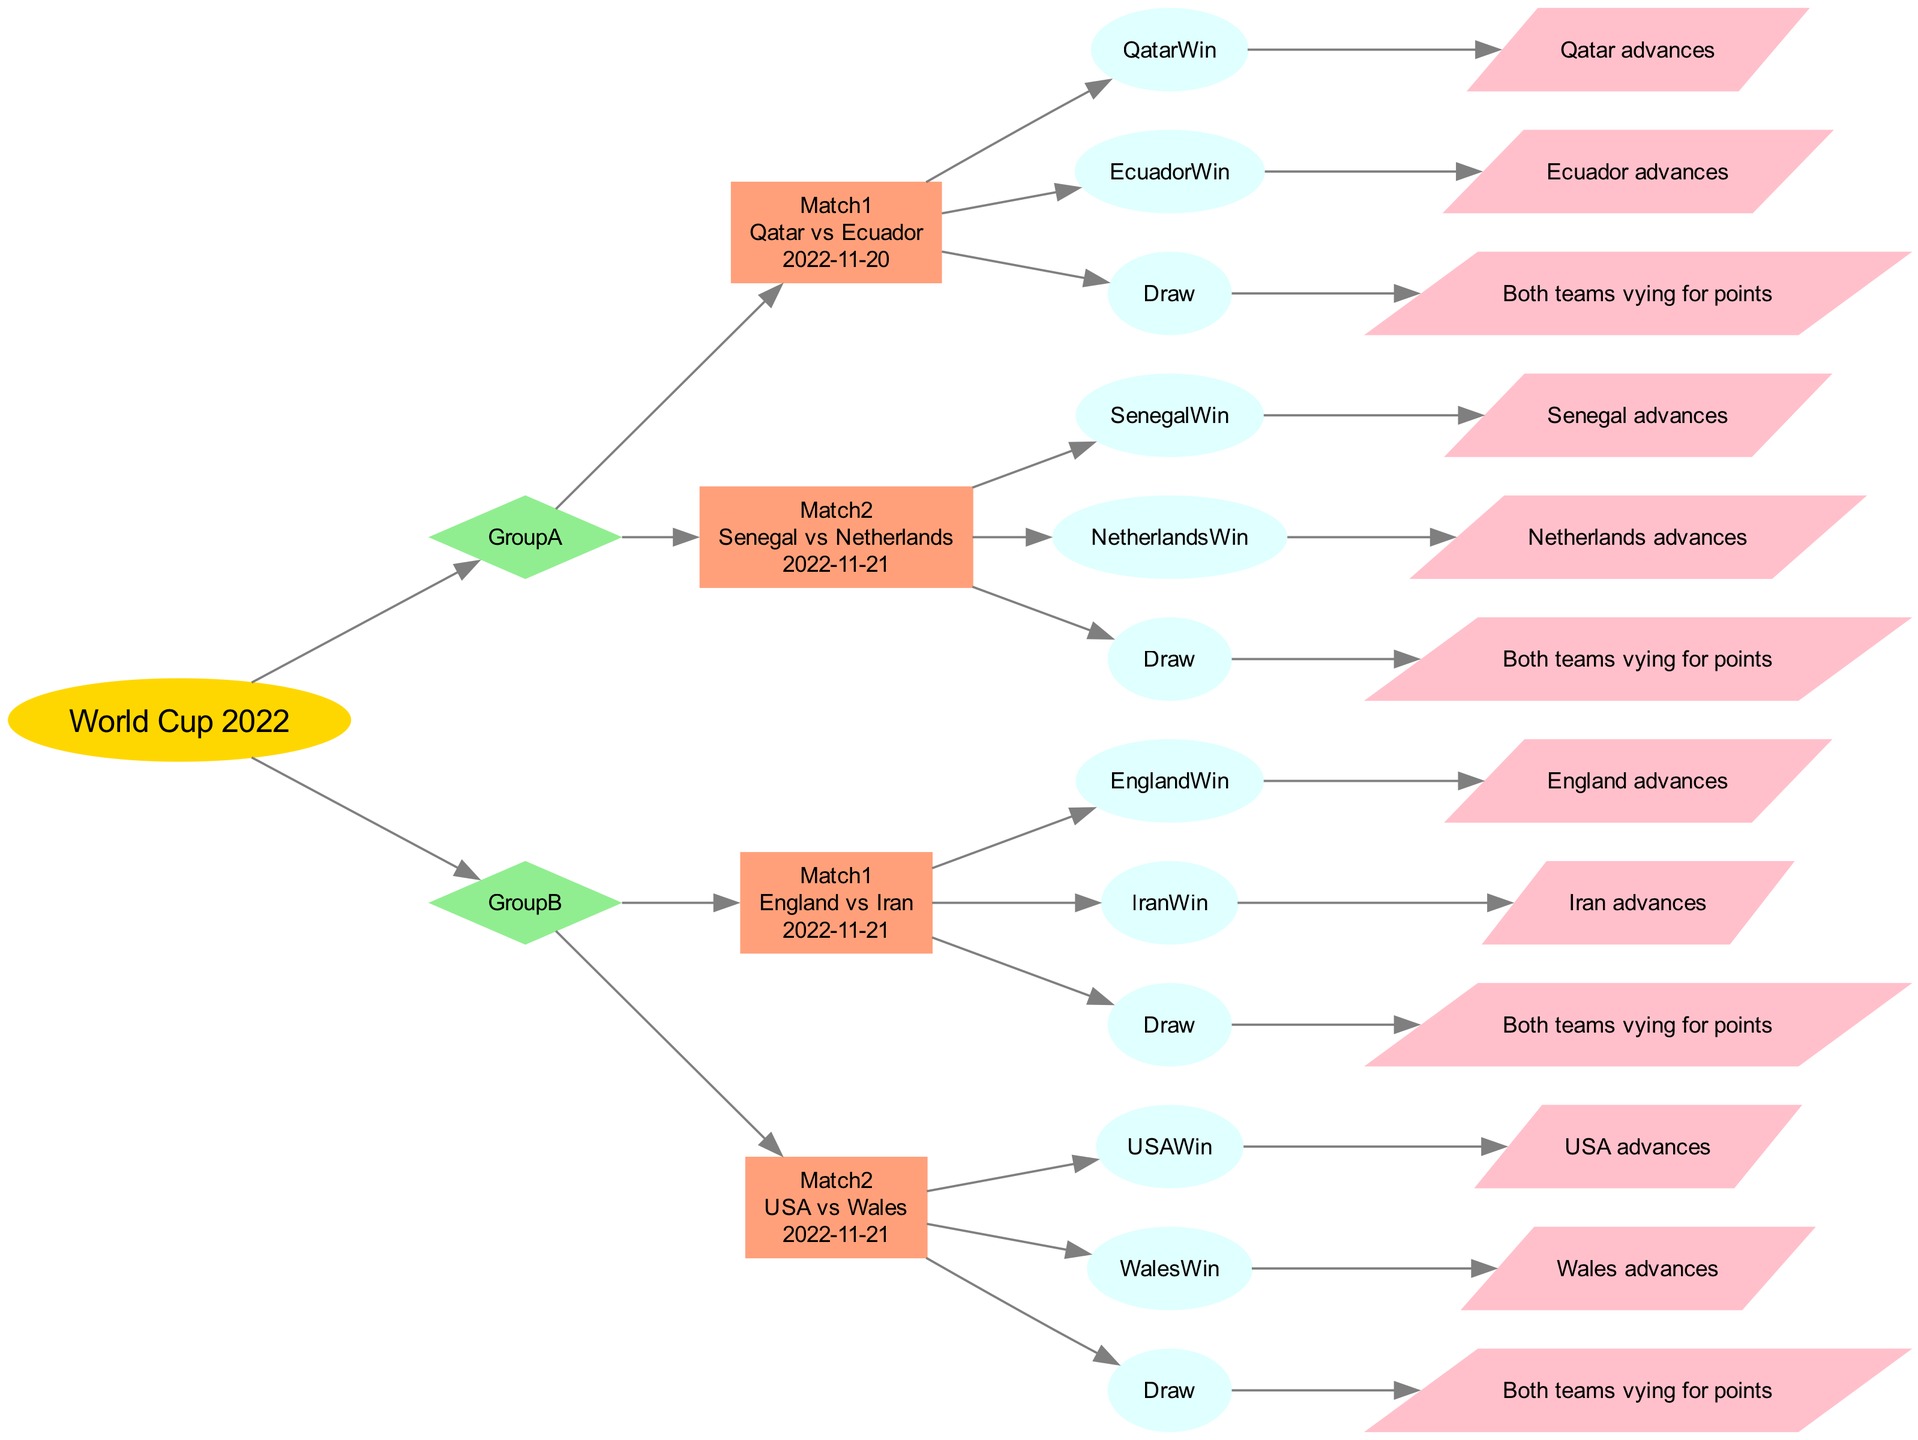What teams are in Group A? In the diagram under Group A, the listed teams are Qatar, Ecuador, Senegal, and Netherlands. These are the teams involved in the matches scheduled in this group stage.
Answer: Qatar, Ecuador, Senegal, Netherlands What is the date of Match 1 in Group B? The diagram specifies that Match 1 in Group B, which features England versus Iran, is scheduled for November 21, 2022. This date is portrayed in the match node for Group B Match 1.
Answer: 2022-11-21 How many matches are shown in Group A? The diagram details two matches indicated by their respective nodes under Group A: Match 1 and Match 2. By counting these two match nodes, we determine the total number of matches in this group.
Answer: 2 What outcome leads to Qatar advancing? The diagram presents the outcome options under Match 1 of Group A, where if Qatar wins, they advance to the next stage. This specific outcome node contains the answer concerning Qatar’s advancement.
Answer: QatarWin Which group has four teams? The diagram shows each group and their respective teams. Upon examining the listed teams, Group A indeed contains four teams, the maximum stated for the groups represented in this decision tree.
Answer: Group A What is the outcome for a draw in Match 2 of Group A? The outcome node related to a draw in Match 2 of Group A indicates that both teams (Senegal and Netherlands) would be vying for points, showing the implications of not having a winner.
Answer: Both teams vying for points What will happen if Iran wins against England? The decision tree specifies that if Iran wins in Match 1 of Group B, then Iran advances to the next stage of the tournament. This is shown as a direct result of that specific outcome in the match.
Answer: Iran advances How many nodes represent outcomes for Match 1 in Group B? In the diagram for Match 1 of Group B, there are three specific nodes that represent the possible outcomes: EnglandWin, IranWin, and Draw. Each of these nodes indicates a possible result for the match.
Answer: 3 What shape is used to represent the World Cup in the diagram? The World Cup node at the top of the decision tree is represented using an oval shape. This design simplifies the visual hierarchy and emphasizes the World Cup as the main event.
Answer: oval Which two teams play in Match 2 of Group B? The diagram indicates that the teams scheduled to play in Match 2 of Group B are USA and Wales, as represented in the match node.
Answer: USA vs Wales 